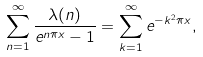Convert formula to latex. <formula><loc_0><loc_0><loc_500><loc_500>\sum _ { n = 1 } ^ { \infty } \frac { \lambda ( n ) } { e ^ { n \pi x } - 1 } = \sum _ { k = 1 } ^ { \infty } e ^ { - k ^ { 2 } \pi x } ,</formula> 